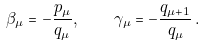<formula> <loc_0><loc_0><loc_500><loc_500>\beta _ { \mu } = - \frac { p _ { \mu } } { q _ { \mu } } , \quad \gamma _ { \mu } = - \frac { q _ { \mu + 1 } } { q _ { \mu } } \, .</formula> 